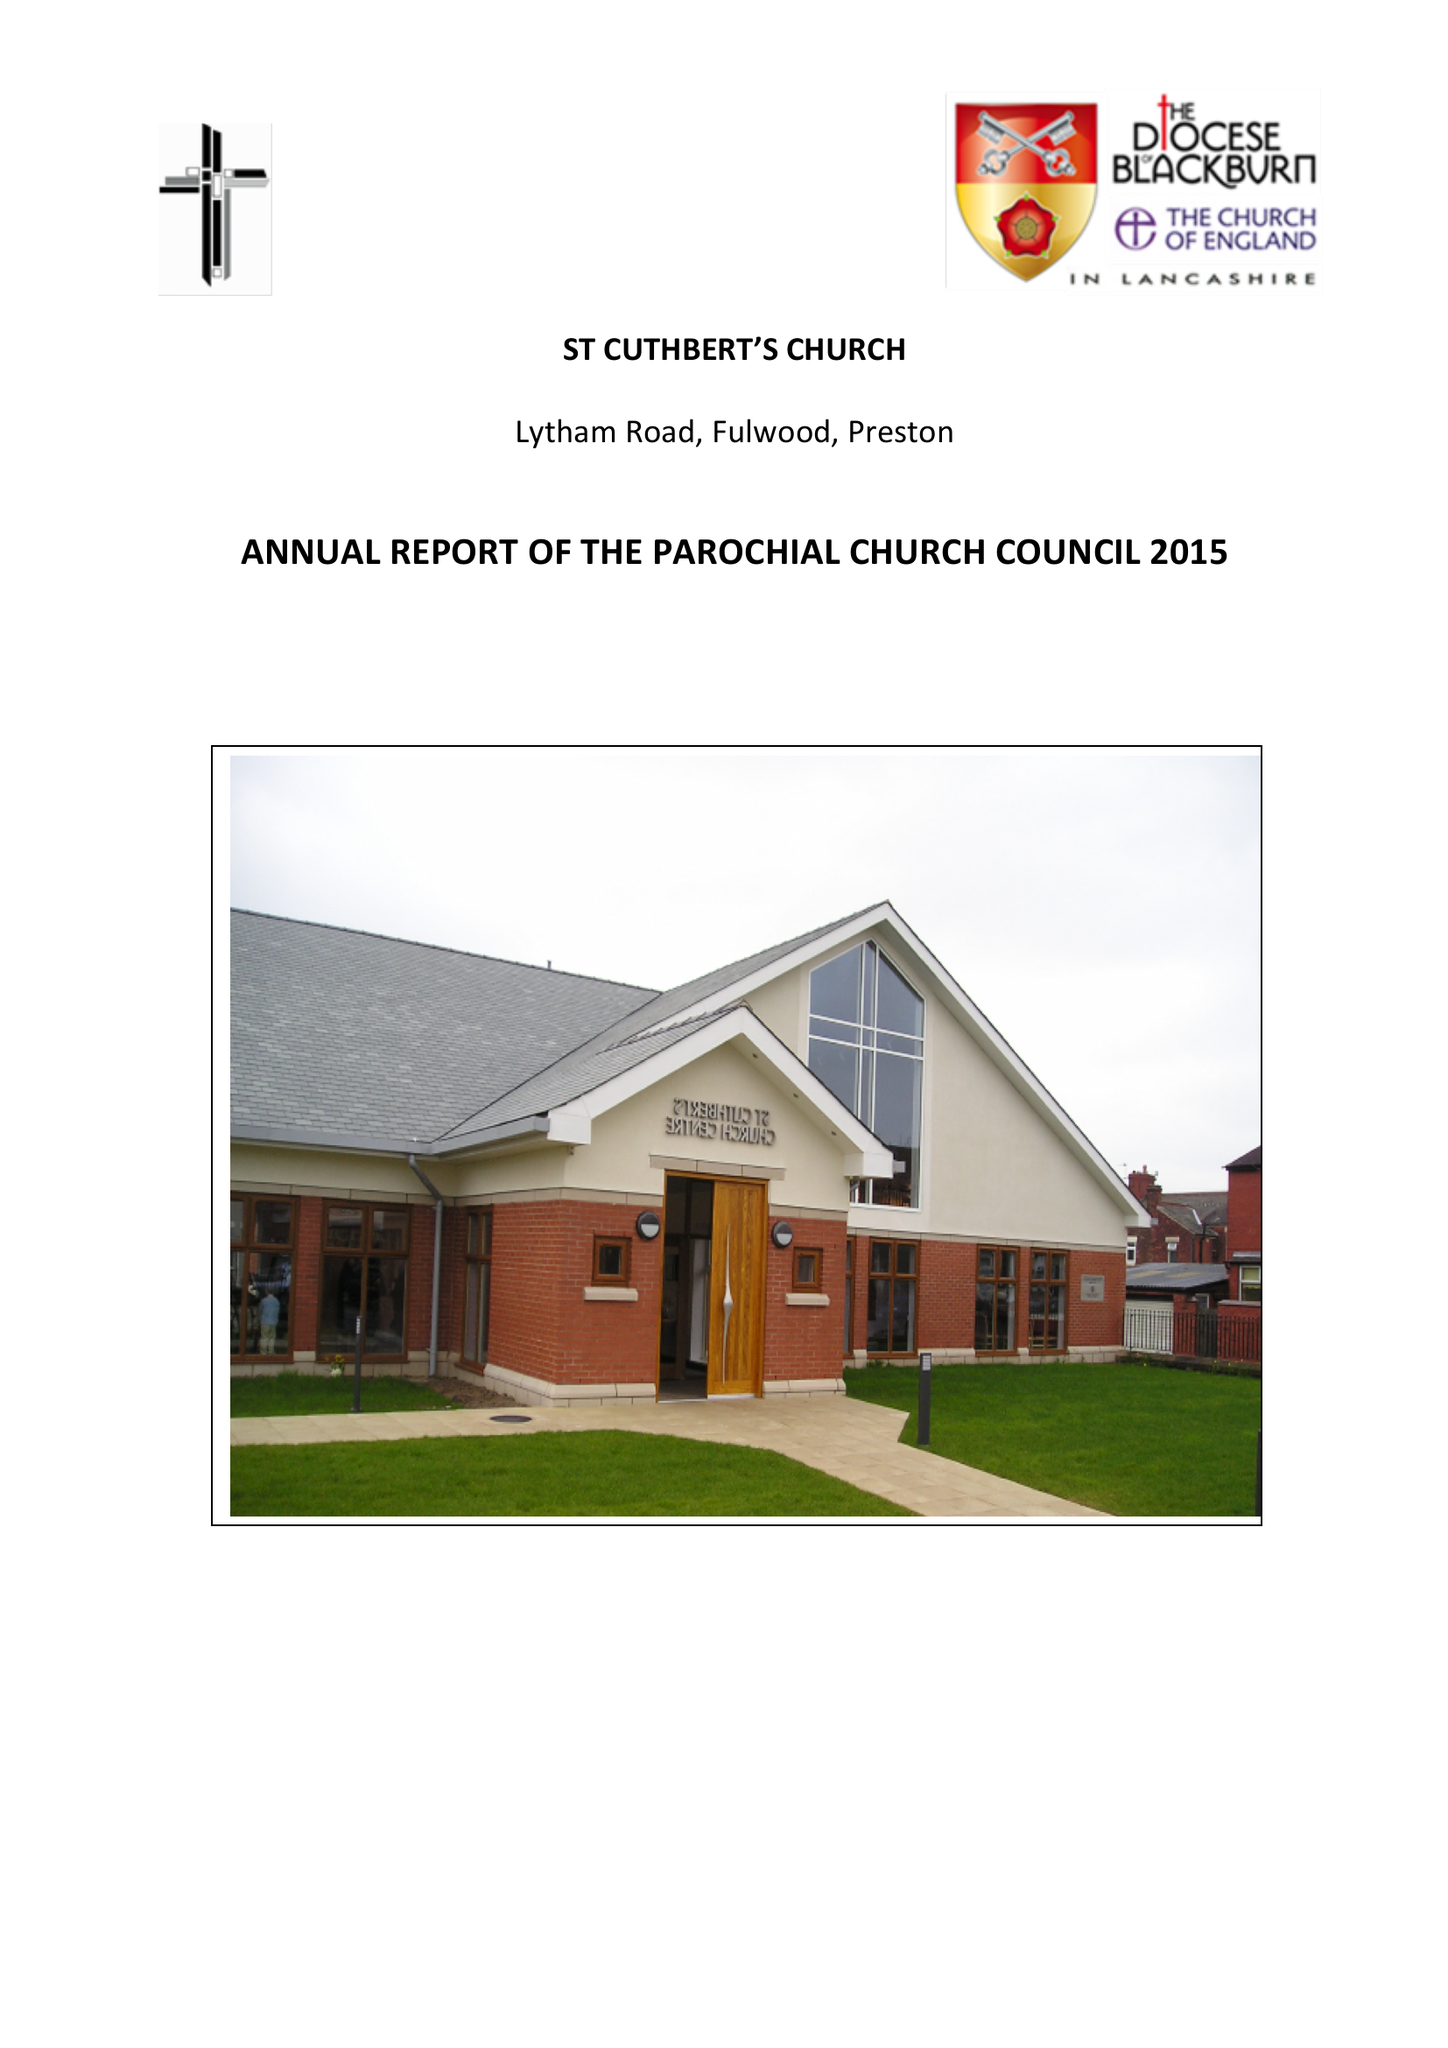What is the value for the charity_number?
Answer the question using a single word or phrase. 1127997 